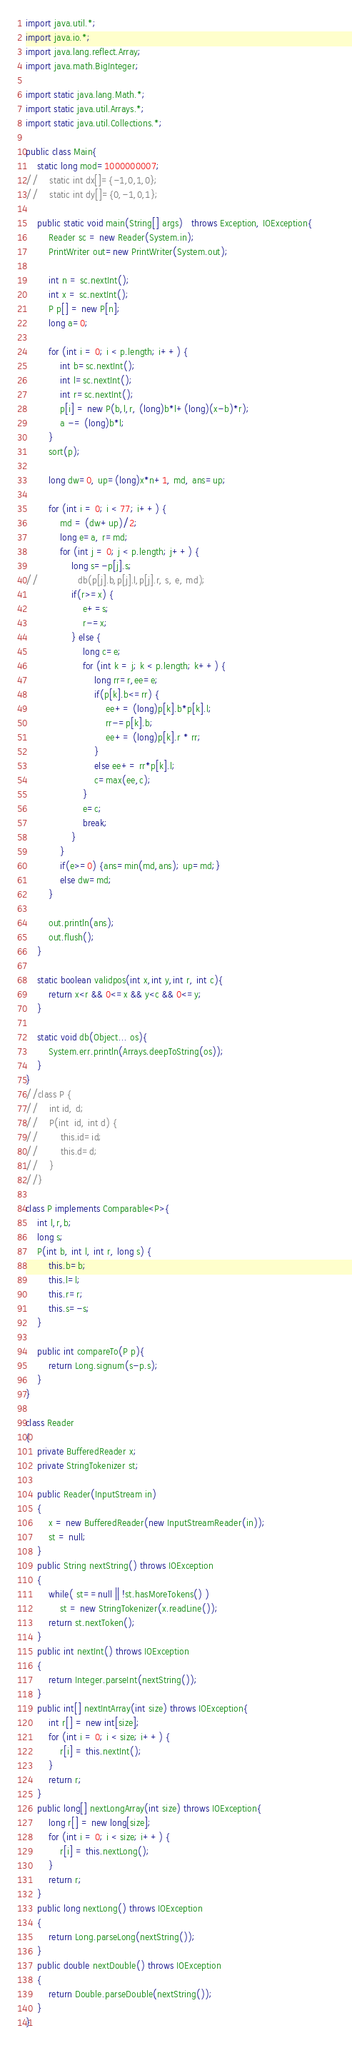Convert code to text. <code><loc_0><loc_0><loc_500><loc_500><_Java_>import java.util.*;
import java.io.*;
import java.lang.reflect.Array;
import java.math.BigInteger;

import static java.lang.Math.*;
import static java.util.Arrays.*;
import static java.util.Collections.*;
 
public class Main{
    static long mod=1000000007;
//    static int dx[]={-1,0,1,0};
//    static int dy[]={0,-1,0,1};

    public static void main(String[] args)   throws Exception, IOException{        
        Reader sc = new Reader(System.in);
        PrintWriter out=new PrintWriter(System.out);

        int n = sc.nextInt();
        int x = sc.nextInt();
        P p[] = new P[n];
        long a=0;
        
        for (int i = 0; i < p.length; i++) {
			int b=sc.nextInt();
			int l=sc.nextInt();
			int r=sc.nextInt();
			p[i] = new P(b,l,r, (long)b*l+(long)(x-b)*r);
			a -= (long)b*l;
		}
        sort(p);
        
        long dw=0, up=(long)x*n+1, md, ans=up;
        
        for (int i = 0; i < 77; i++) {
			md = (dw+up)/2;
			long e=a, r=md;
			for (int j = 0; j < p.length; j++) {
				long s=-p[j].s;
//				db(p[j].b,p[j].l,p[j].r, s, e, md);
				if(r>=x) {
					e+=s;
					r-=x;
				} else {
					long c=e;
					for (int k = j; k < p.length; k++) {
						long rr=r,ee=e;
						if(p[k].b<=rr) {
							ee+= (long)p[k].b*p[k].l;
							rr-=p[k].b;
							ee+= (long)p[k].r * rr;
						}
						else ee+= rr*p[k].l;
						c=max(ee,c);
					}
					e=c;
					break;
				}
			}
			if(e>=0) {ans=min(md,ans); up=md;}
			else dw=md;
		}
        
        out.println(ans);
        out.flush();
    }

    static boolean validpos(int x,int y,int r, int c){
        return x<r && 0<=x && y<c && 0<=y;
    }

    static void db(Object... os){
        System.err.println(Arrays.deepToString(os));
    }
}
//class P {
//    int id, d;
//    P(int  id, int d) {
//        this.id=id;
//        this.d=d;
//    }
//}

class P implements Comparable<P>{
    int l,r,b;
    long s;
    P(int b, int l, int r, long s) {
    	this.b=b;
    	this.l=l;
        this.r=r;
        this.s=-s;
    }

    public int compareTo(P p){
        return Long.signum(s-p.s);
    }
}

class Reader
{ 
    private BufferedReader x;
    private StringTokenizer st;
    
    public Reader(InputStream in)
    {
        x = new BufferedReader(new InputStreamReader(in));
        st = null;
    }
    public String nextString() throws IOException
    {
        while( st==null || !st.hasMoreTokens() )
            st = new StringTokenizer(x.readLine());
        return st.nextToken();
    }
    public int nextInt() throws IOException
    {
        return Integer.parseInt(nextString());
    }
    public int[] nextIntArray(int size) throws IOException{
        int r[] = new int[size];
        for (int i = 0; i < size; i++) {
            r[i] = this.nextInt(); 
        }
        return r;
    }
    public long[] nextLongArray(int size) throws IOException{
        long r[] = new long[size];
        for (int i = 0; i < size; i++) {
            r[i] = this.nextLong(); 
        }
        return r;
    }
    public long nextLong() throws IOException
    {
        return Long.parseLong(nextString());
    }
    public double nextDouble() throws IOException
    {
        return Double.parseDouble(nextString());
    }
}
</code> 